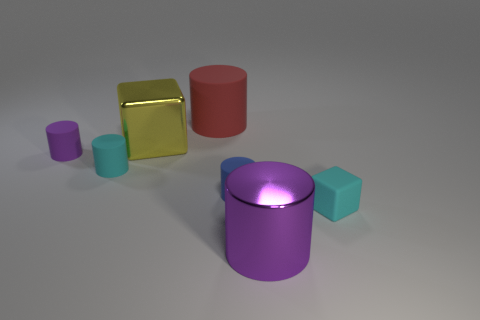Subtract all cyan rubber cylinders. How many cylinders are left? 4 Subtract all cyan cylinders. How many cylinders are left? 4 Subtract all green cylinders. Subtract all blue blocks. How many cylinders are left? 5 Add 1 green things. How many objects exist? 8 Subtract all cylinders. How many objects are left? 2 Add 7 cyan matte objects. How many cyan matte objects exist? 9 Subtract 1 cyan blocks. How many objects are left? 6 Subtract all purple cylinders. Subtract all small cyan rubber objects. How many objects are left? 3 Add 6 small cyan matte cylinders. How many small cyan matte cylinders are left? 7 